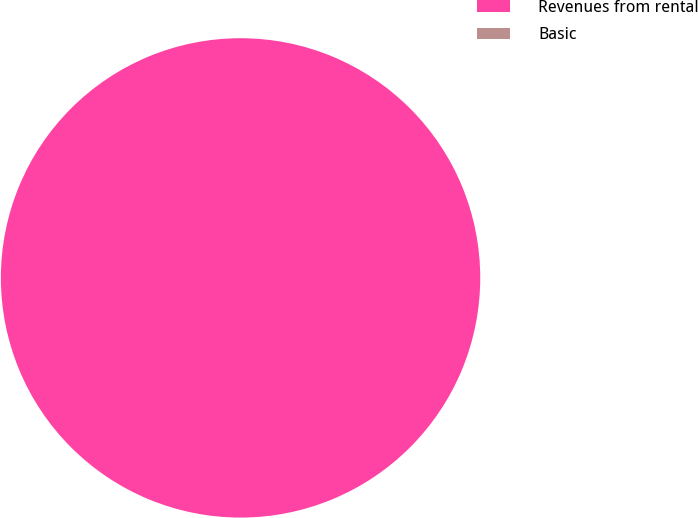<chart> <loc_0><loc_0><loc_500><loc_500><pie_chart><fcel>Revenues from rental<fcel>Basic<nl><fcel>100.0%<fcel>0.0%<nl></chart> 